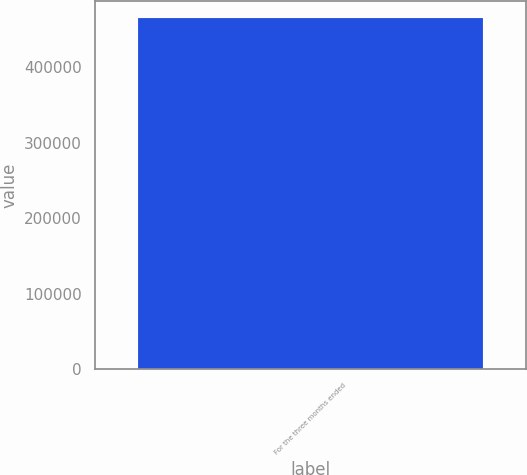Convert chart. <chart><loc_0><loc_0><loc_500><loc_500><bar_chart><fcel>For the three months ended<nl><fcel>464924<nl></chart> 